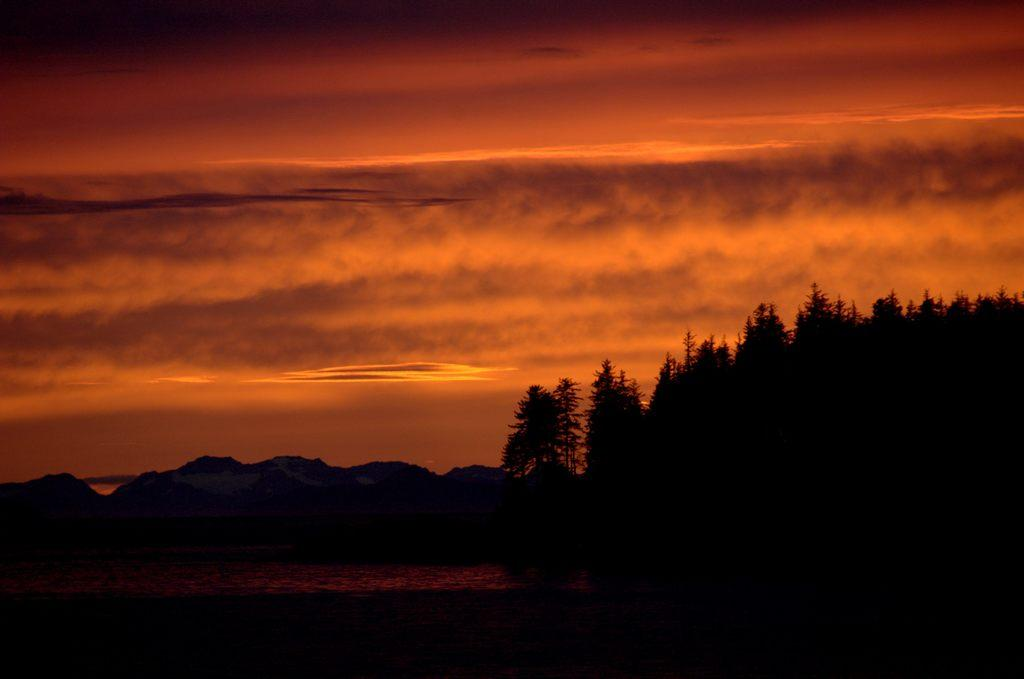What type of vegetation can be seen in the image? There are trees in the image. What part of the natural environment is visible in the image? The sky is visible in the background of the image. What type of drink is being served at the school bus stop in the image? There is no mention of a school, bus stop, or drink in the image; it only features trees and the sky. 